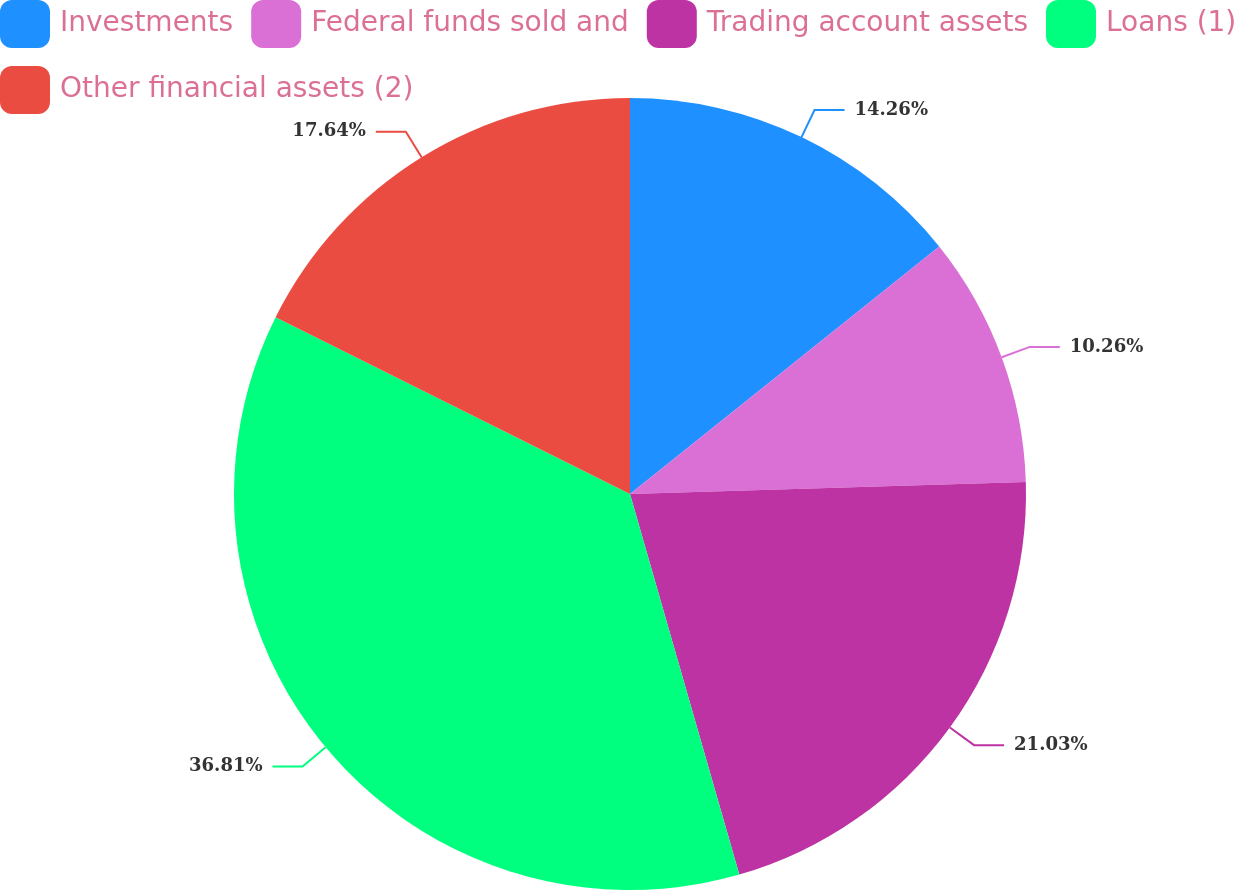Convert chart to OTSL. <chart><loc_0><loc_0><loc_500><loc_500><pie_chart><fcel>Investments<fcel>Federal funds sold and<fcel>Trading account assets<fcel>Loans (1)<fcel>Other financial assets (2)<nl><fcel>14.26%<fcel>10.26%<fcel>21.03%<fcel>36.81%<fcel>17.64%<nl></chart> 